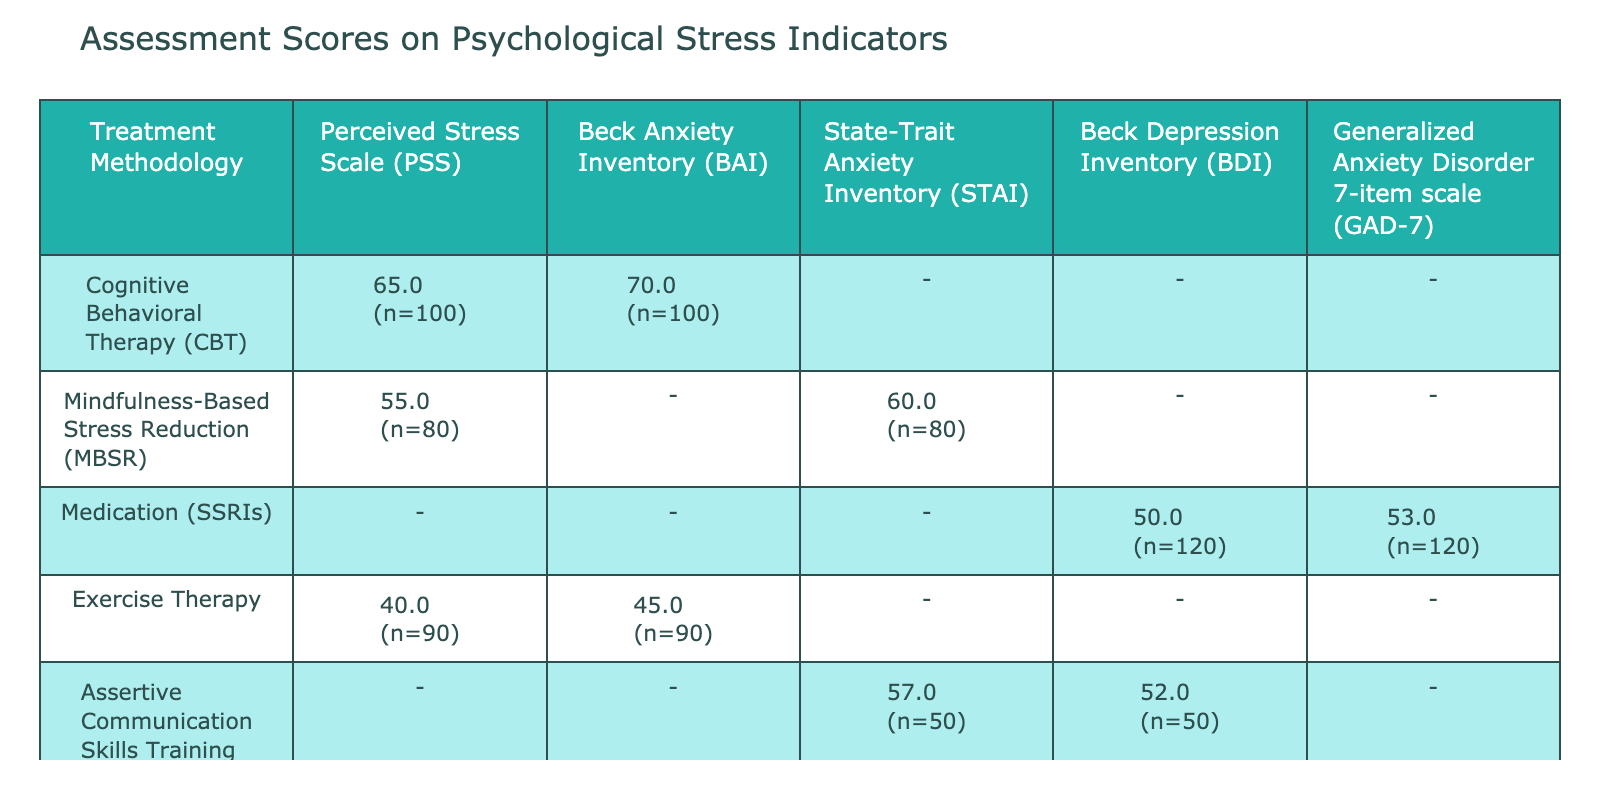What is the assessment score for Exercise Therapy on the Perceived Stress Scale? The table shows that for Exercise Therapy, the assessment score on the Perceived Stress Scale is 40.
Answer: 40 Which treatment methodology has the highest score on the Beck Anxiety Inventory? From the table, the Cognitive Behavioral Therapy has the highest score of 70 on the Beck Anxiety Inventory, compared to Exercise Therapy with 45.
Answer: Cognitive Behavioral Therapy Is the assessment score for Medication (SSRIs) higher on the Beck Depression Inventory than on the Generalized Anxiety Disorder 7-item scale? The score for Medication (SSRIs) on the Beck Depression Inventory is 50, while on the Generalized Anxiety Disorder 7-item scale it is 53. Since 50 is less than 53, the statement is false.
Answer: No What is the average assessment score across all psychological stress indicators for Mindfulness-Based Stress Reduction? The assessment scores for Mindfulness-Based Stress Reduction are 55 (PSS) and 60 (STAI). Adding them gives 115, and dividing by 2 (as there are 2 indicators) gives an average of 57.5.
Answer: 57.5 Which treatment methodologies scored below 60 on the Perceived Stress Scale? From the table, only Exercise Therapy scored 40, while Cognitive Behavioral Therapy scored 65 which is above 60. Thus, the only treatment methodology that scored below 60 is Exercise Therapy.
Answer: Exercise Therapy How many treatment methodologies have scores on the Beck Depression Inventory? There are two treatment methodologies listed with scores on the Beck Depression Inventory: Medication (SSRIs) with a score of 50 and Assertive Communication Skills Training with a score of 52. Therefore, the total count is 2.
Answer: 2 What is the difference in assessment scores between Cognitive Behavioral Therapy and Medication (SSRIs) on the Beck Anxiety Inventory? The score for Cognitive Behavioral Therapy on the Beck Anxiety Inventory is 70, and for Medication (SSRIs), it is 53. Calculating the difference, 70 - 53 equals 17.
Answer: 17 Which psychological stress indicator had the lowest score across all treatment methodologies? Reviewing the table, the lowest assessment score appears to be for Exercise Therapy on the Perceived Stress Scale, which is 40.
Answer: 40 Do both treatment methodologies that involve Assertive Communication Skills Training have scores above 50? The scores for Assertive Communication Skills Training are 57 (for STAI) and 52 (for BDI). Both scores are indeed above 50, thus the answer is yes.
Answer: Yes 